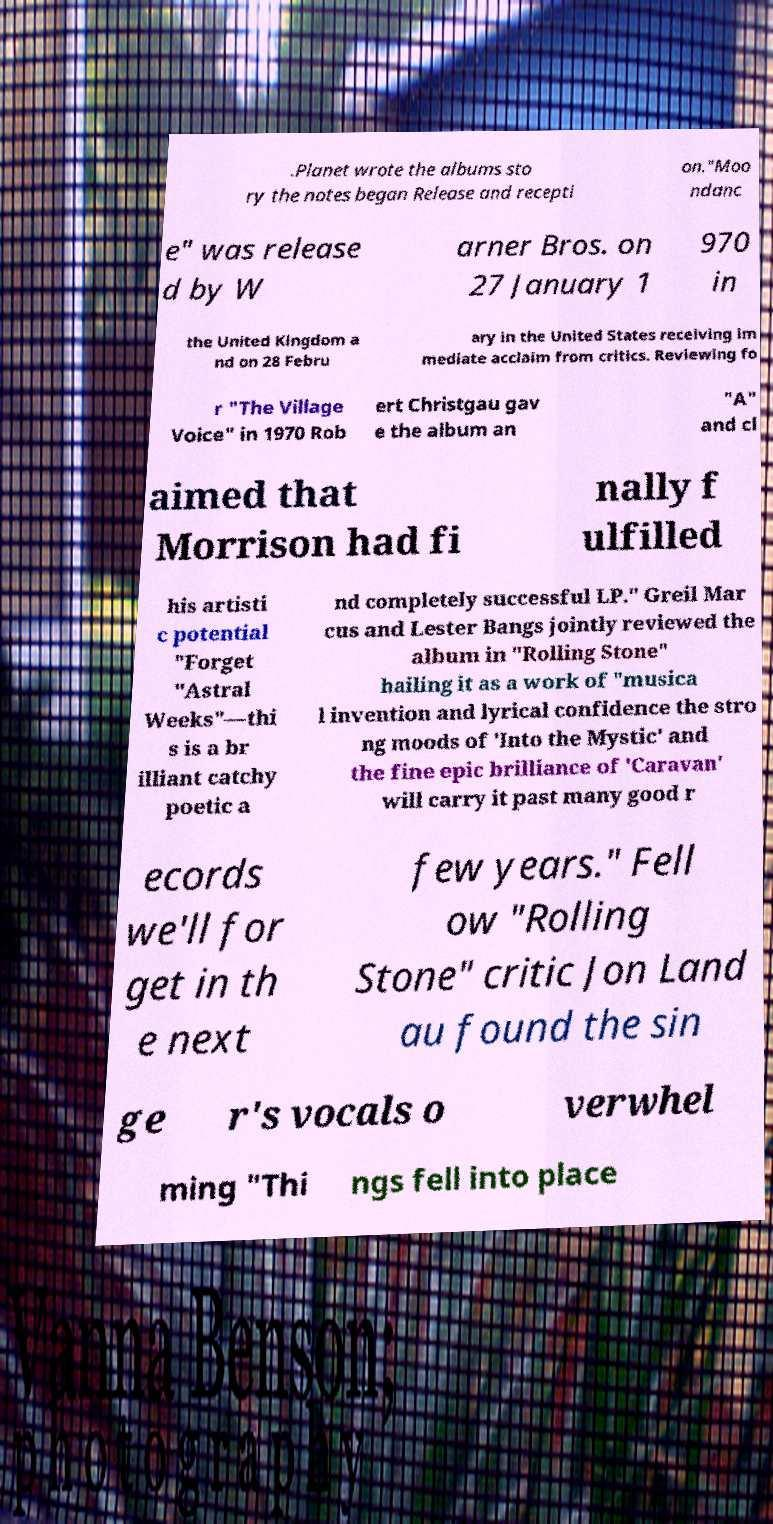Can you read and provide the text displayed in the image?This photo seems to have some interesting text. Can you extract and type it out for me? .Planet wrote the albums sto ry the notes began Release and recepti on."Moo ndanc e" was release d by W arner Bros. on 27 January 1 970 in the United Kingdom a nd on 28 Febru ary in the United States receiving im mediate acclaim from critics. Reviewing fo r "The Village Voice" in 1970 Rob ert Christgau gav e the album an "A" and cl aimed that Morrison had fi nally f ulfilled his artisti c potential "Forget "Astral Weeks"—thi s is a br illiant catchy poetic a nd completely successful LP." Greil Mar cus and Lester Bangs jointly reviewed the album in "Rolling Stone" hailing it as a work of "musica l invention and lyrical confidence the stro ng moods of 'Into the Mystic' and the fine epic brilliance of 'Caravan' will carry it past many good r ecords we'll for get in th e next few years." Fell ow "Rolling Stone" critic Jon Land au found the sin ge r's vocals o verwhel ming "Thi ngs fell into place 